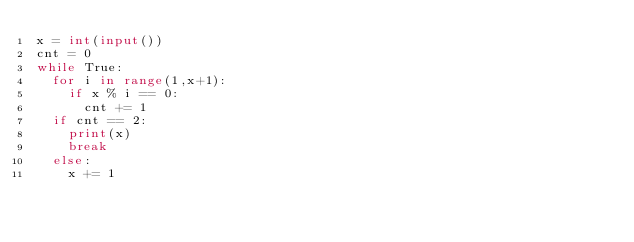Convert code to text. <code><loc_0><loc_0><loc_500><loc_500><_Python_>x = int(input())
cnt = 0
while True:
  for i in range(1,x+1):
    if x % i == 0:
      cnt += 1
  if cnt == 2:
    print(x)
    break
  else:
    x += 1</code> 